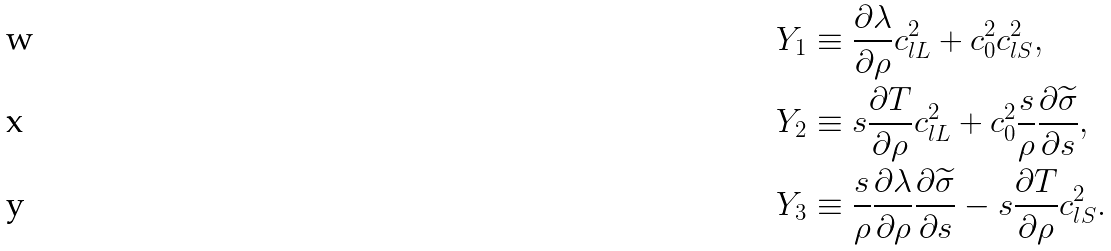Convert formula to latex. <formula><loc_0><loc_0><loc_500><loc_500>Y _ { 1 } & \equiv \frac { \partial \lambda } { \partial \rho } c _ { l L } ^ { 2 } + c _ { 0 } ^ { 2 } c _ { l S } ^ { 2 } , \\ Y _ { 2 } & \equiv s \frac { \partial T } { \partial \rho } { c } _ { l L } ^ { 2 } + c _ { 0 } ^ { 2 } \frac { s } { \rho } \frac { \partial \widetilde { \sigma } } { \partial s } , \\ Y _ { 3 } & \equiv \frac { s } { \rho } \frac { \partial \lambda } { \partial \rho } \frac { \partial \widetilde { \sigma } } { \partial s } - s \frac { \partial T } { \partial \rho } c _ { l S } ^ { 2 } .</formula> 